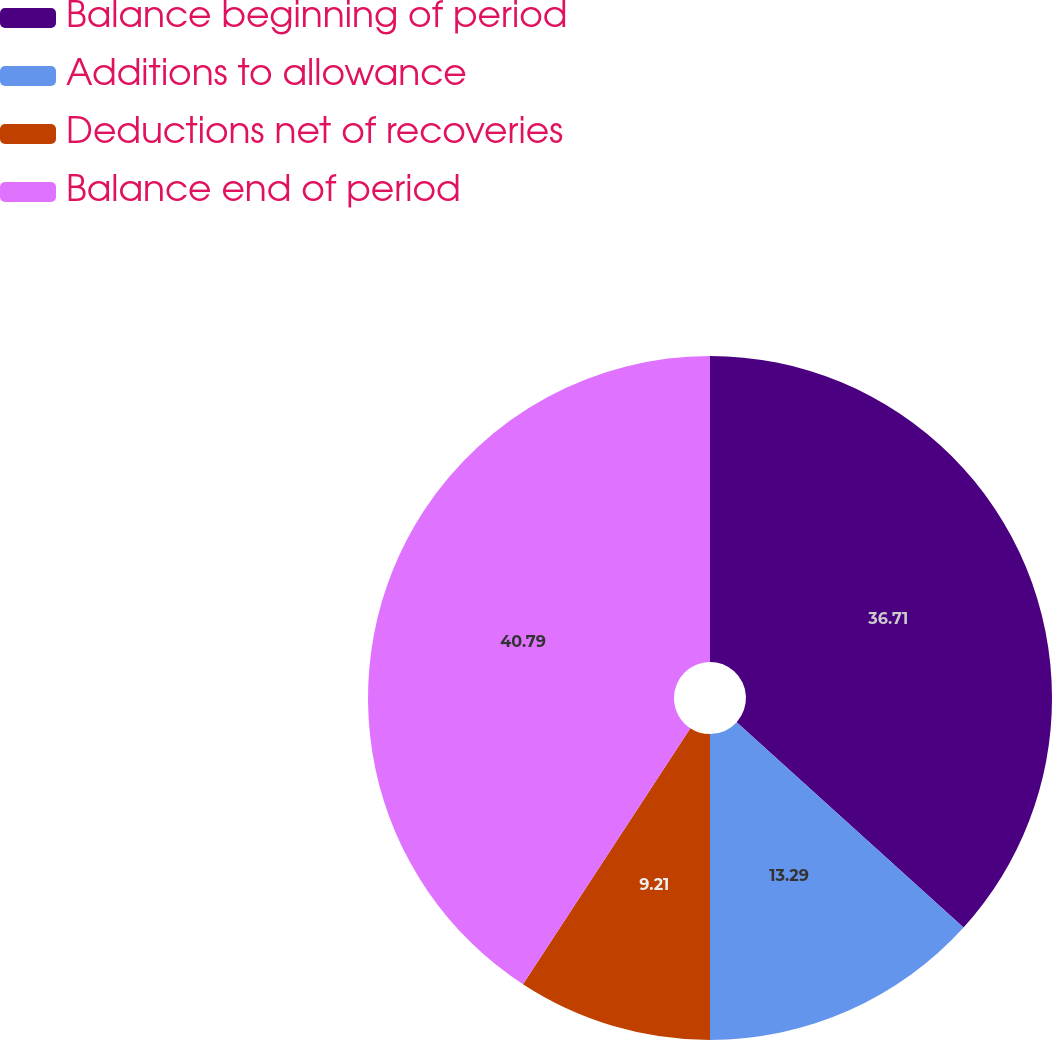Convert chart to OTSL. <chart><loc_0><loc_0><loc_500><loc_500><pie_chart><fcel>Balance beginning of period<fcel>Additions to allowance<fcel>Deductions net of recoveries<fcel>Balance end of period<nl><fcel>36.71%<fcel>13.29%<fcel>9.21%<fcel>40.79%<nl></chart> 